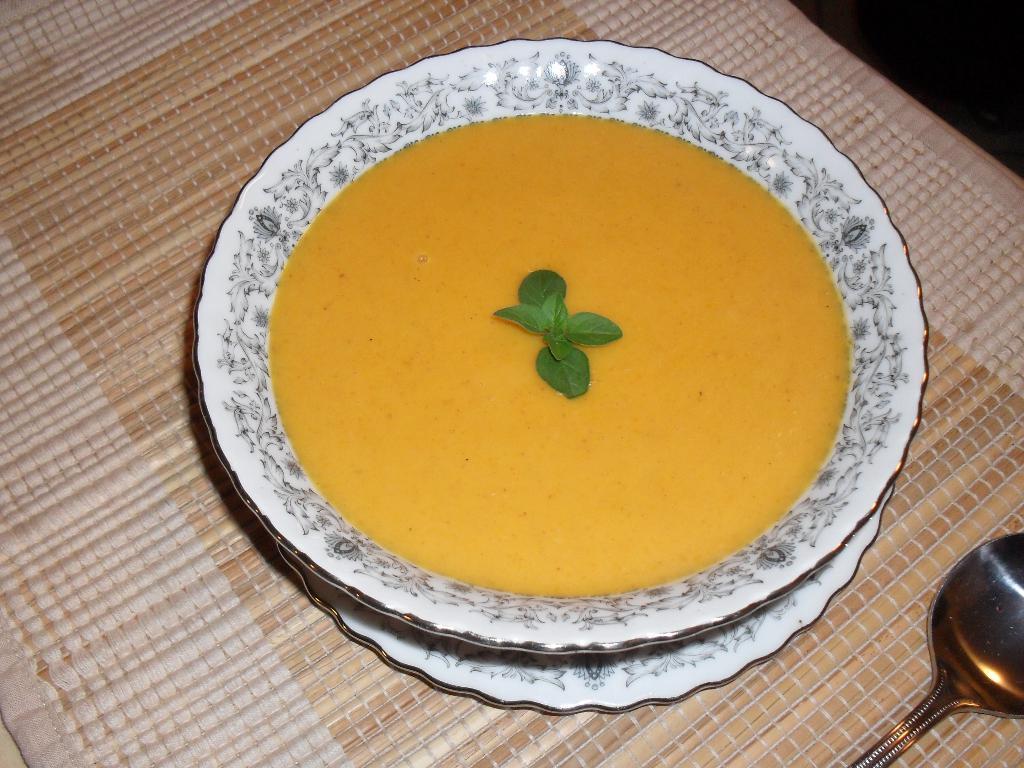Describe this image in one or two sentences. In this image I can see a mat which is placed on a table. On the mat there is a plate which consists of soup. In the middle of the soup there are few leaves. In the bottom right there is a spoon. 